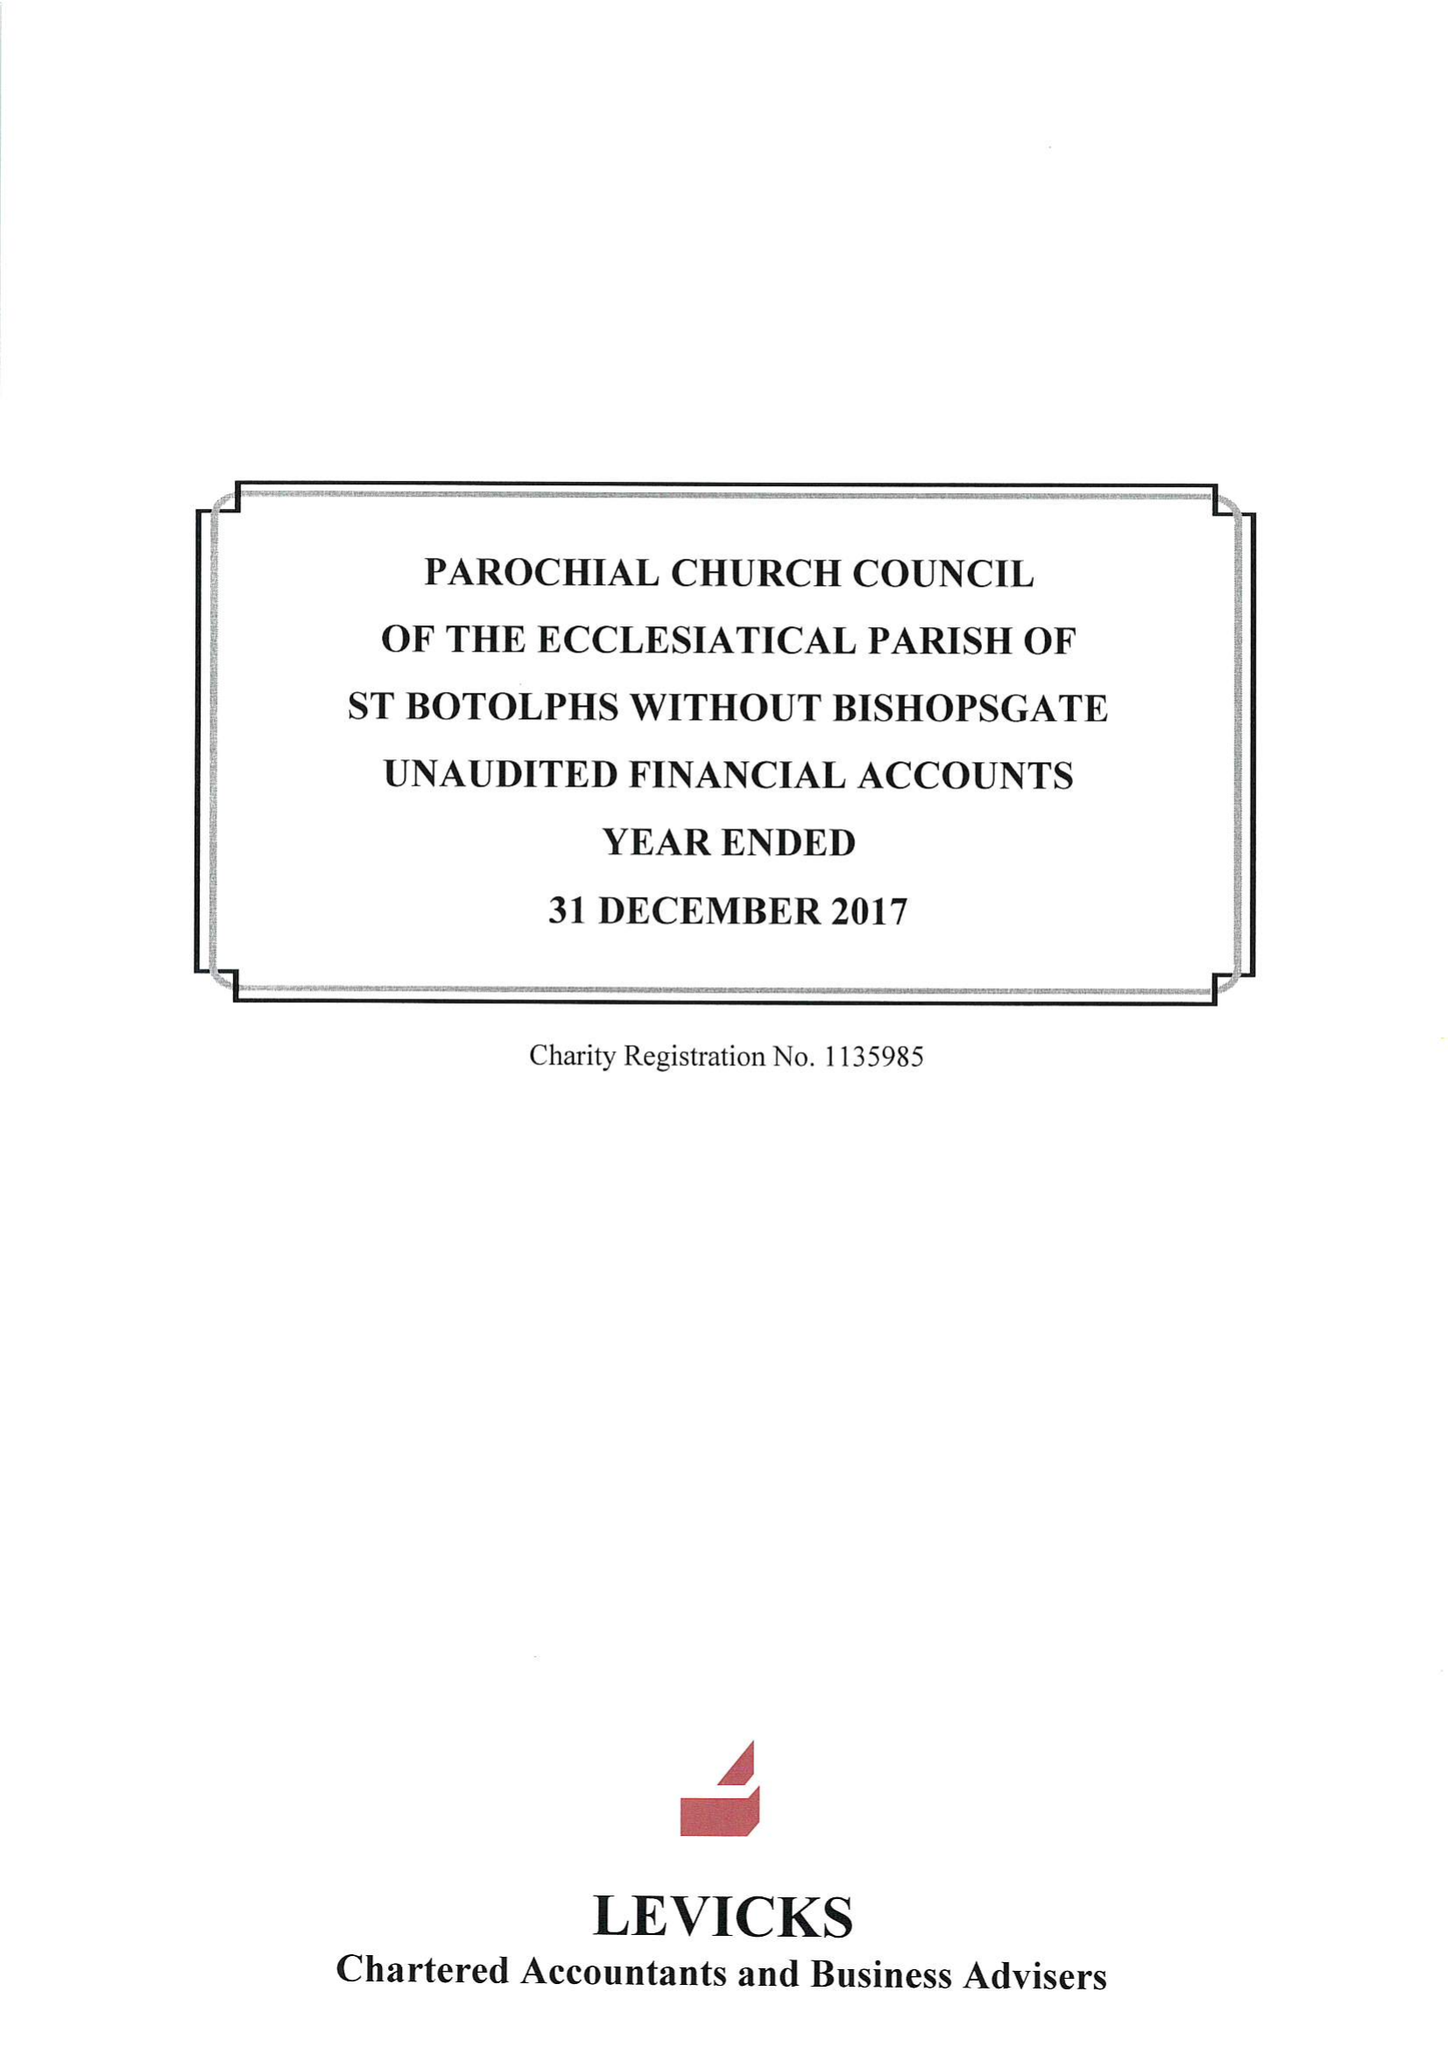What is the value for the charity_name?
Answer the question using a single word or phrase. The Parochial Church Council Of The Ecclesiastical Parish Of St Botolph-Without-Bishopsgate 